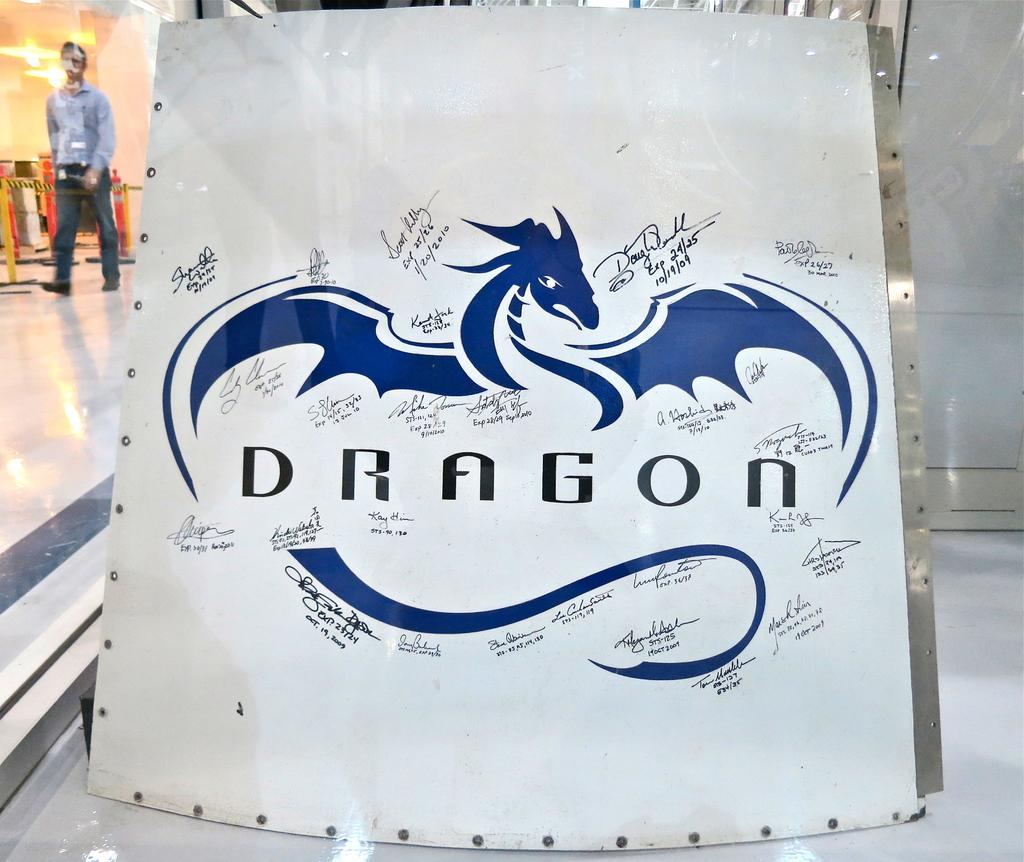What is the main object in the image? There is a cardboard in the image. What is depicted on the cardboard? The cardboard has a dragon image on it. How does the team of firefighters extinguish the fire in the image? There is no team of firefighters or fire present in the image; it only features a cardboard with a dragon image on it. 